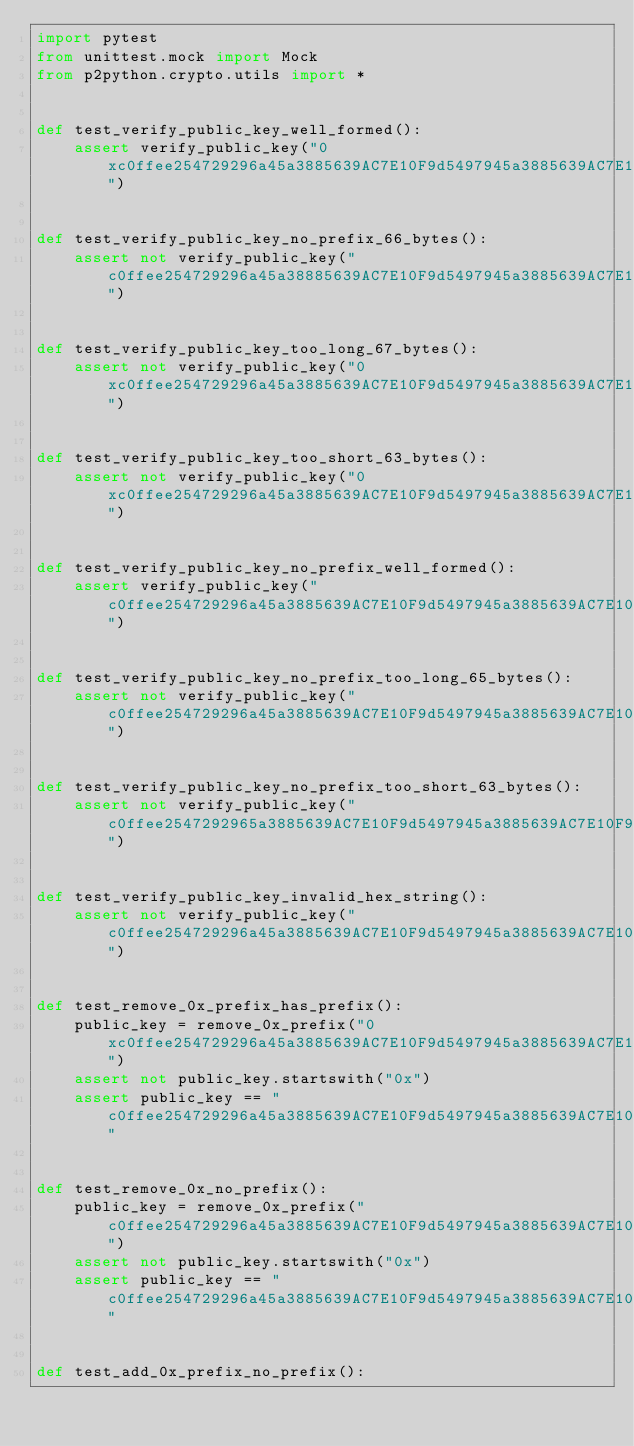Convert code to text. <code><loc_0><loc_0><loc_500><loc_500><_Python_>import pytest
from unittest.mock import Mock
from p2python.crypto.utils import *


def test_verify_public_key_well_formed():
    assert verify_public_key("0xc0ffee254729296a45a3885639AC7E10F9d5497945a3885639AC7E10F9d54979")


def test_verify_public_key_no_prefix_66_bytes():
    assert not verify_public_key("c0ffee254729296a45a38885639AC7E10F9d5497945a3885639AC7E10F9d549792")


def test_verify_public_key_too_long_67_bytes():
    assert not verify_public_key("0xc0ffee254729296a45a3885639AC7E10F9d5497945a3885639AC7E10F9d549792")


def test_verify_public_key_too_short_63_bytes():
    assert not verify_public_key("0xc0ffee254729296a45a3885639AC7E10F9d5497945a3885639AC7E10F9d54")


def test_verify_public_key_no_prefix_well_formed():
    assert verify_public_key("c0ffee254729296a45a3885639AC7E10F9d5497945a3885639AC7E10F9d54979")


def test_verify_public_key_no_prefix_too_long_65_bytes():
    assert not verify_public_key("c0ffee254729296a45a3885639AC7E10F9d5497945a3885639AC7E10F9d549791")


def test_verify_public_key_no_prefix_too_short_63_bytes():
    assert not verify_public_key("c0ffee2547292965a3885639AC7E10F9d5497945a3885639AC7E10F9d549791")


def test_verify_public_key_invalid_hex_string():
    assert not verify_public_key("c0ffee254729296a45a3885639AC7E10F9d5497945a3885639AC7E10F9d5497p")


def test_remove_0x_prefix_has_prefix():
    public_key = remove_0x_prefix("0xc0ffee254729296a45a3885639AC7E10F9d5497945a3885639AC7E10F9d54979")
    assert not public_key.startswith("0x")
    assert public_key == "c0ffee254729296a45a3885639AC7E10F9d5497945a3885639AC7E10F9d54979"


def test_remove_0x_no_prefix():
    public_key = remove_0x_prefix("c0ffee254729296a45a3885639AC7E10F9d5497945a3885639AC7E10F9d54979")
    assert not public_key.startswith("0x")
    assert public_key == "c0ffee254729296a45a3885639AC7E10F9d5497945a3885639AC7E10F9d54979"


def test_add_0x_prefix_no_prefix():</code> 